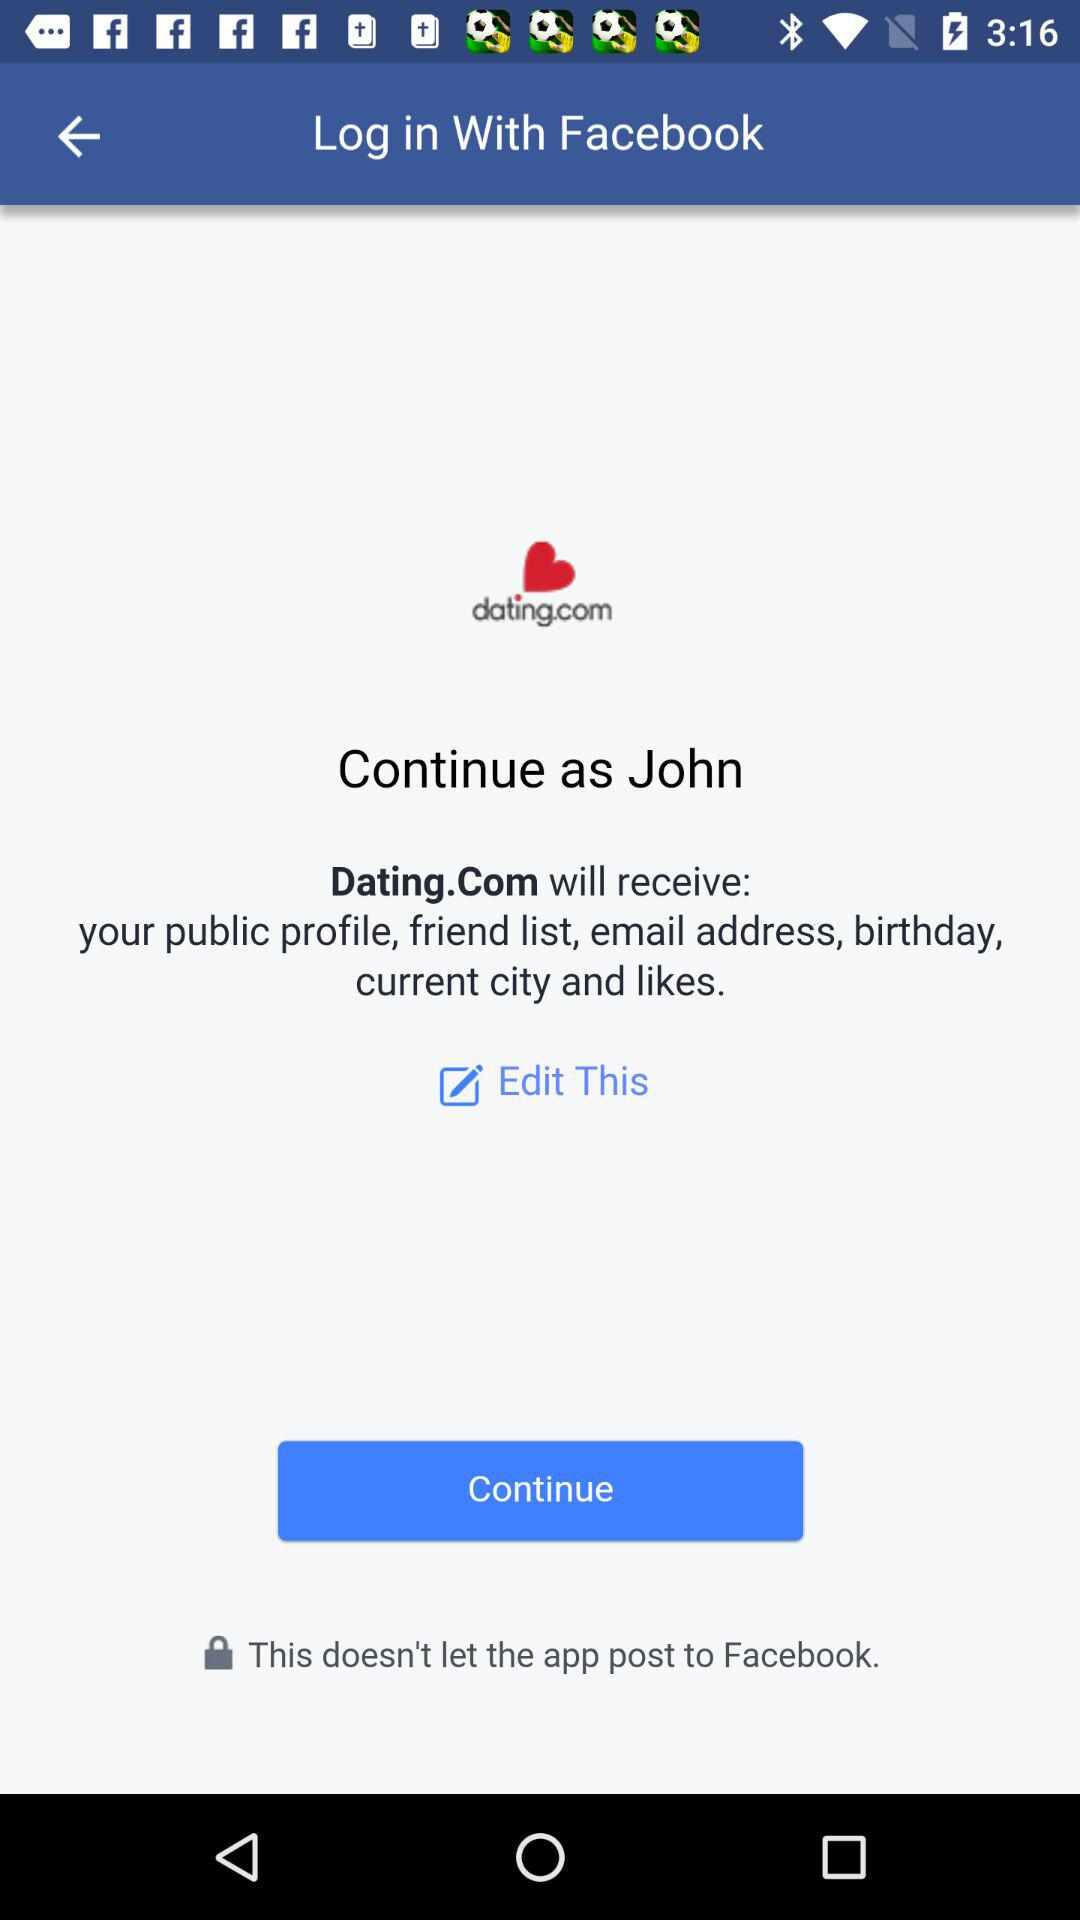What is the user name to continue the profile? The user name is John. 